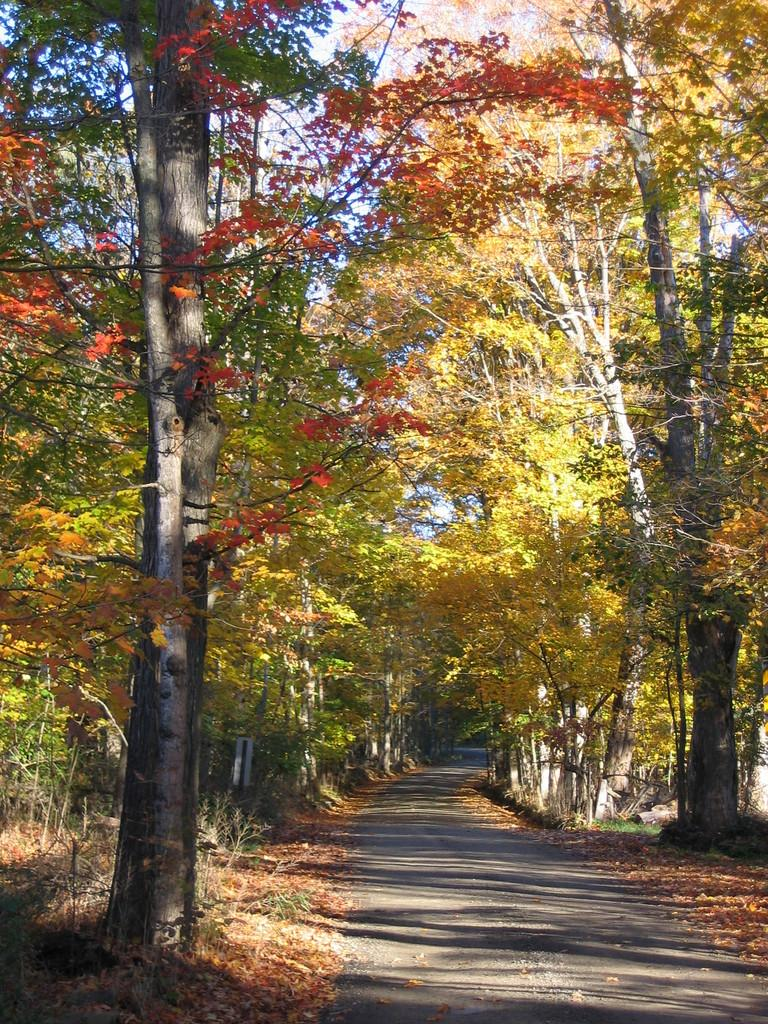What type of vegetation is present in the image? There are many trees, plants, and grass in the image. Where is the road located in the image? The road is at the bottom of the image. What is located beside the road? There are leaves beside the road. What can be seen at the top of the image? The sky is visible at the top of the image. What type of beam is holding up the trees in the image? There is no beam present in the image; the trees are standing on their own. What route can be taken to reach the plants in the image? The image does not provide information about a specific route to reach the plants; it only shows their presence. 